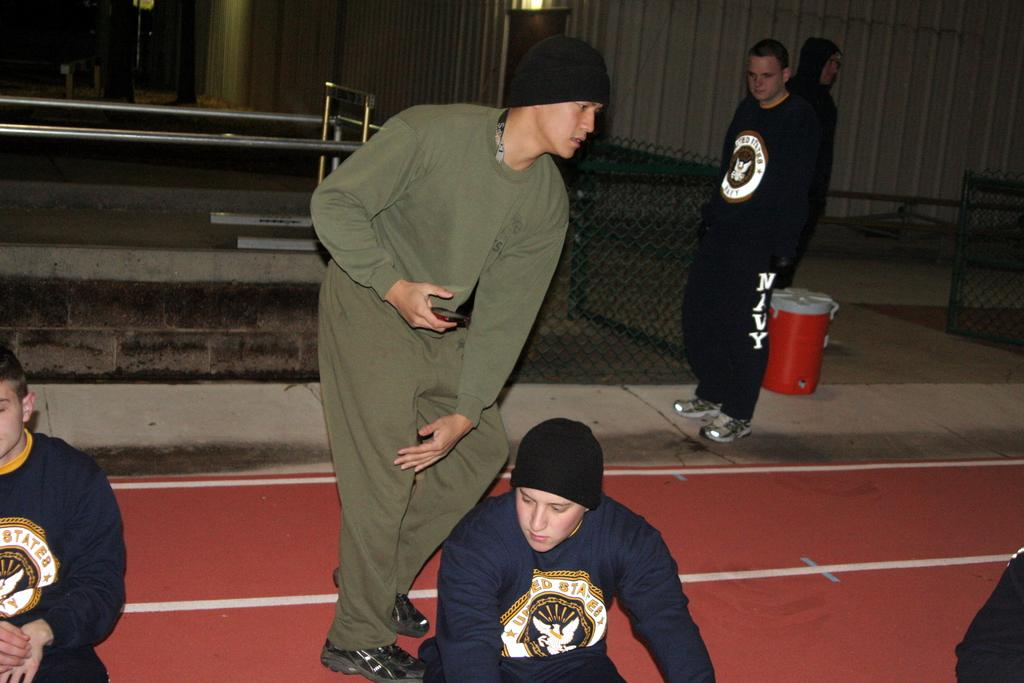Provide a one-sentence caption for the provided image. Several men are around a track, one is wearing sweatpants that say Navy on them. 